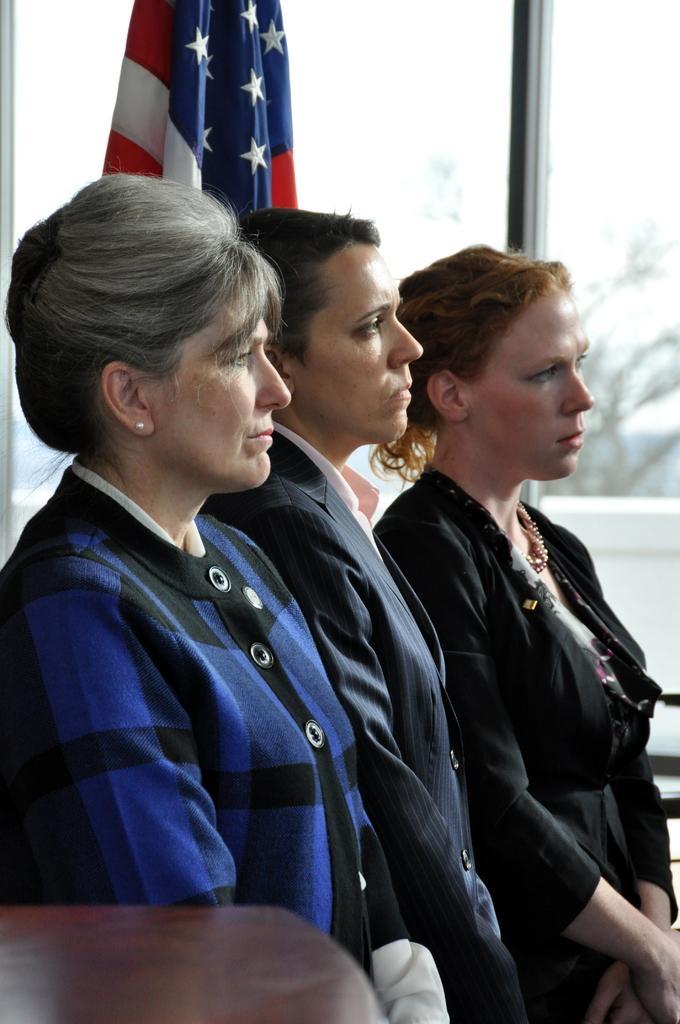Describe this image in one or two sentences. In the center of the image there is a woman. In the background we can see flag, tree and windows. 